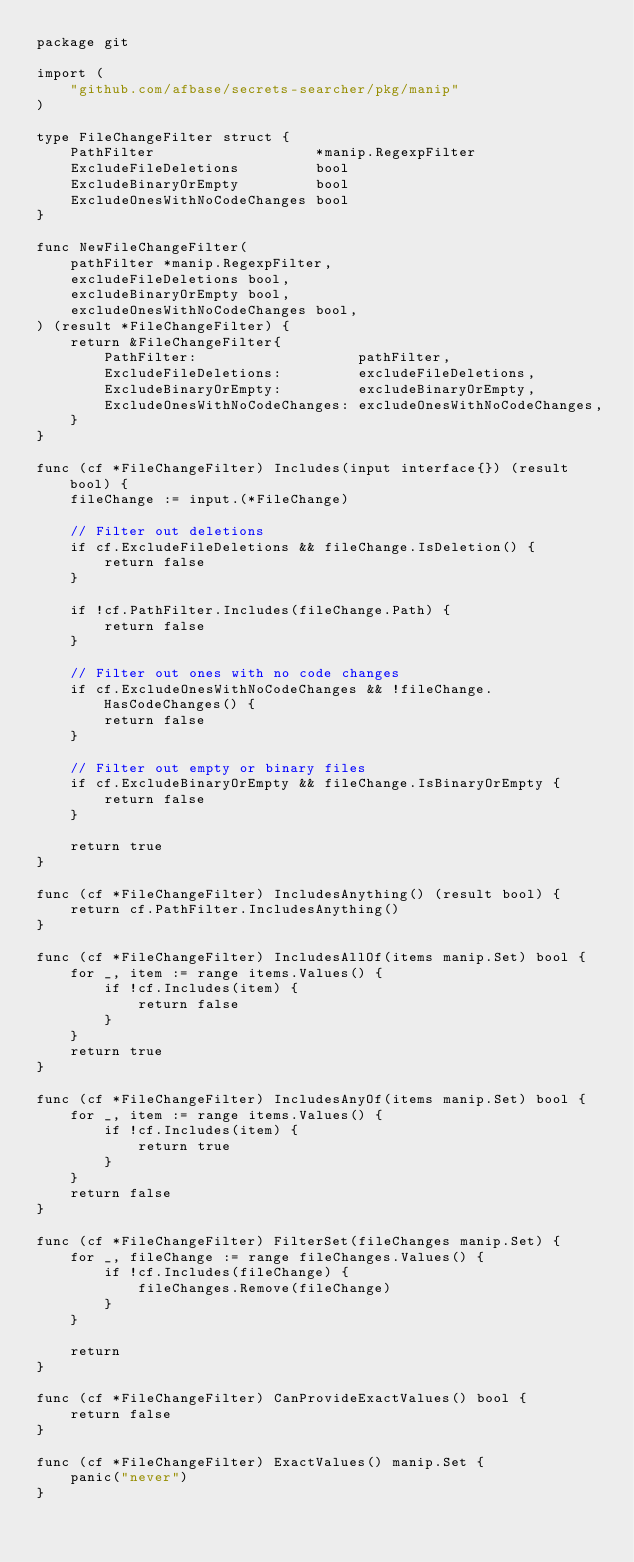<code> <loc_0><loc_0><loc_500><loc_500><_Go_>package git

import (
	"github.com/afbase/secrets-searcher/pkg/manip"
)

type FileChangeFilter struct {
	PathFilter                   *manip.RegexpFilter
	ExcludeFileDeletions         bool
	ExcludeBinaryOrEmpty         bool
	ExcludeOnesWithNoCodeChanges bool
}

func NewFileChangeFilter(
	pathFilter *manip.RegexpFilter,
	excludeFileDeletions bool,
	excludeBinaryOrEmpty bool,
	excludeOnesWithNoCodeChanges bool,
) (result *FileChangeFilter) {
	return &FileChangeFilter{
		PathFilter:                   pathFilter,
		ExcludeFileDeletions:         excludeFileDeletions,
		ExcludeBinaryOrEmpty:         excludeBinaryOrEmpty,
		ExcludeOnesWithNoCodeChanges: excludeOnesWithNoCodeChanges,
	}
}

func (cf *FileChangeFilter) Includes(input interface{}) (result bool) {
	fileChange := input.(*FileChange)

	// Filter out deletions
	if cf.ExcludeFileDeletions && fileChange.IsDeletion() {
		return false
	}

	if !cf.PathFilter.Includes(fileChange.Path) {
		return false
	}

	// Filter out ones with no code changes
	if cf.ExcludeOnesWithNoCodeChanges && !fileChange.HasCodeChanges() {
		return false
	}

	// Filter out empty or binary files
	if cf.ExcludeBinaryOrEmpty && fileChange.IsBinaryOrEmpty {
		return false
	}

	return true
}

func (cf *FileChangeFilter) IncludesAnything() (result bool) {
	return cf.PathFilter.IncludesAnything()
}

func (cf *FileChangeFilter) IncludesAllOf(items manip.Set) bool {
	for _, item := range items.Values() {
		if !cf.Includes(item) {
			return false
		}
	}
	return true
}

func (cf *FileChangeFilter) IncludesAnyOf(items manip.Set) bool {
	for _, item := range items.Values() {
		if !cf.Includes(item) {
			return true
		}
	}
	return false
}

func (cf *FileChangeFilter) FilterSet(fileChanges manip.Set) {
	for _, fileChange := range fileChanges.Values() {
		if !cf.Includes(fileChange) {
			fileChanges.Remove(fileChange)
		}
	}

	return
}

func (cf *FileChangeFilter) CanProvideExactValues() bool {
	return false
}

func (cf *FileChangeFilter) ExactValues() manip.Set {
	panic("never")
}
</code> 